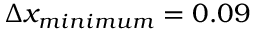<formula> <loc_0><loc_0><loc_500><loc_500>\Delta x _ { \min i m u m } = 0 . 0 9</formula> 